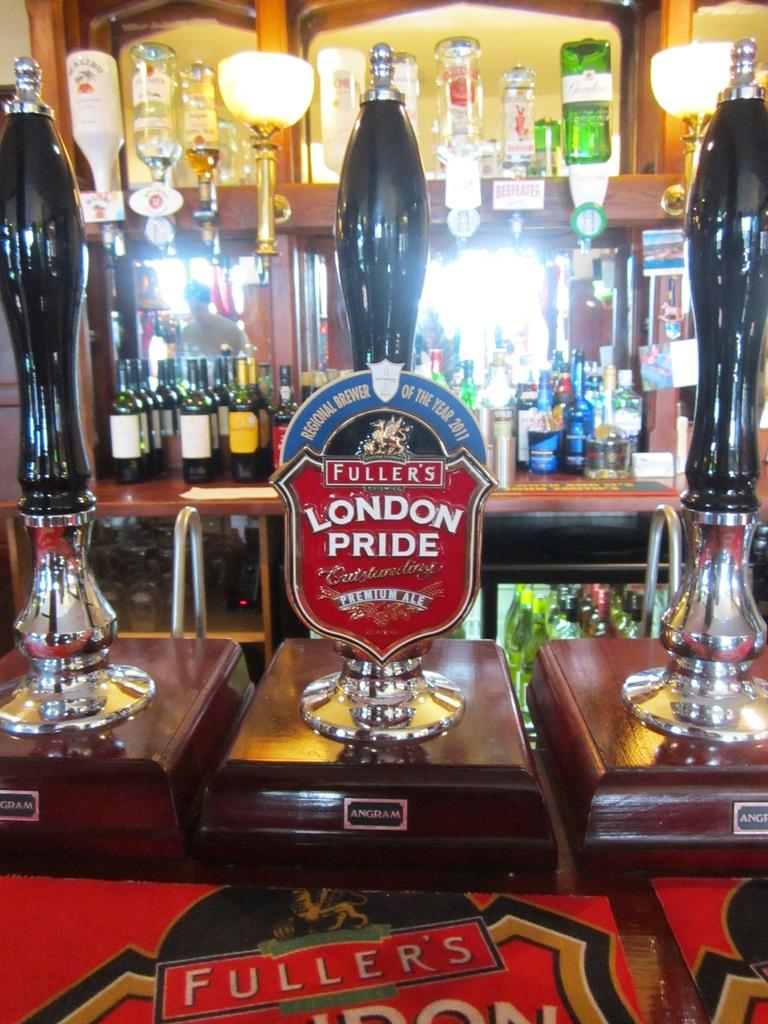What brand of beer is the red handle for?
Your response must be concise. London pride. 